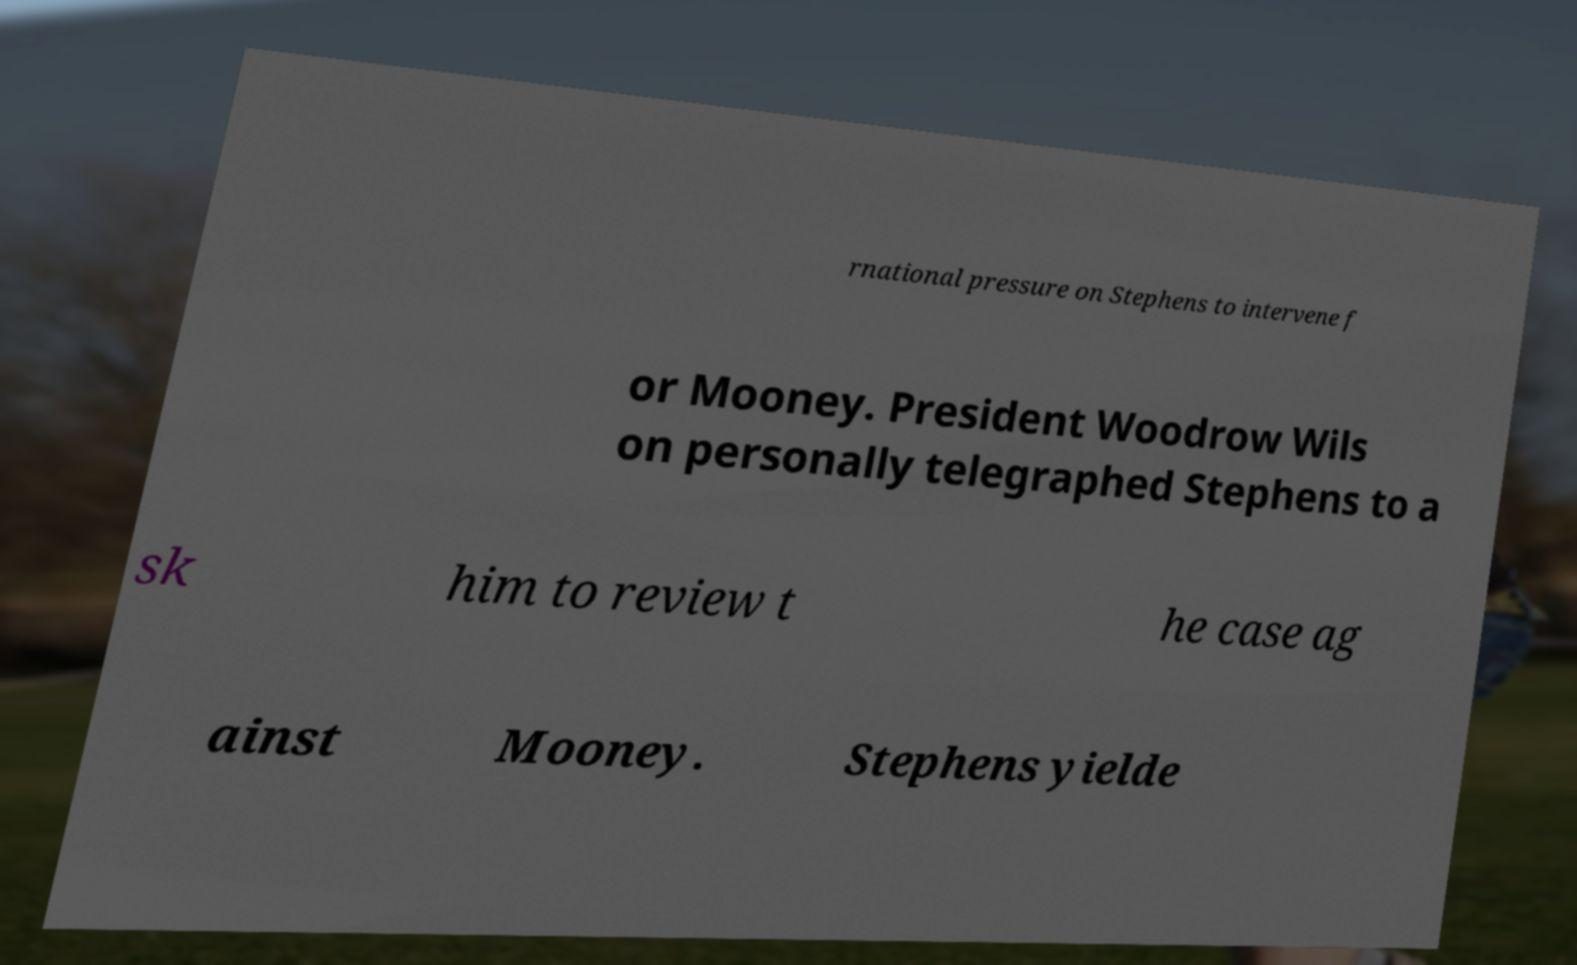Please identify and transcribe the text found in this image. rnational pressure on Stephens to intervene f or Mooney. President Woodrow Wils on personally telegraphed Stephens to a sk him to review t he case ag ainst Mooney. Stephens yielde 